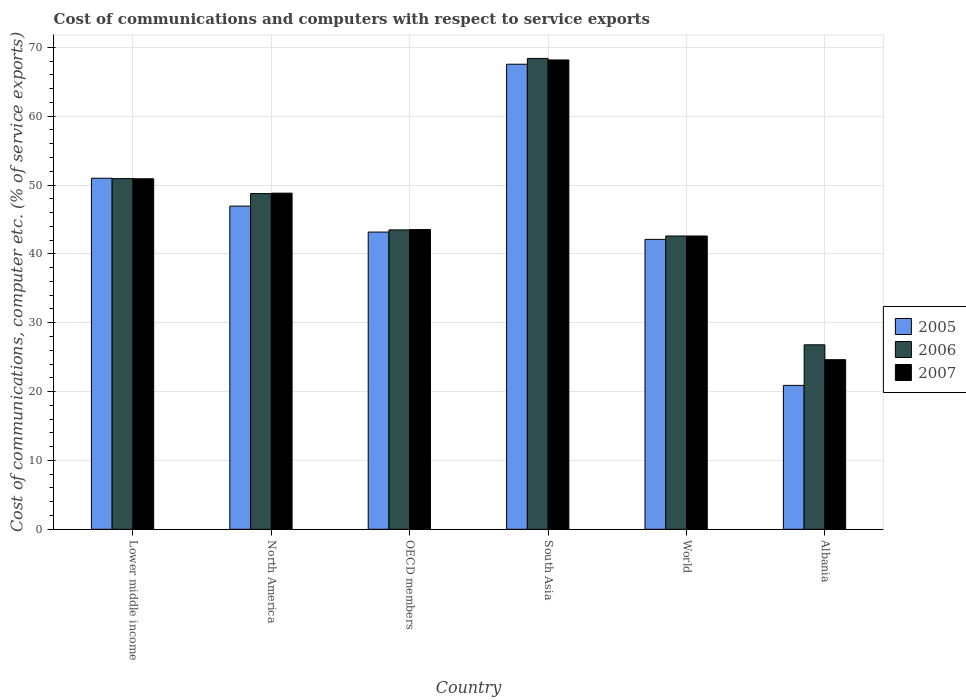Are the number of bars on each tick of the X-axis equal?
Give a very brief answer. Yes. What is the label of the 3rd group of bars from the left?
Offer a terse response. OECD members. What is the cost of communications and computers in 2005 in World?
Your answer should be compact. 42.1. Across all countries, what is the maximum cost of communications and computers in 2005?
Your answer should be compact. 67.54. Across all countries, what is the minimum cost of communications and computers in 2005?
Offer a terse response. 20.9. In which country was the cost of communications and computers in 2005 maximum?
Offer a very short reply. South Asia. In which country was the cost of communications and computers in 2007 minimum?
Give a very brief answer. Albania. What is the total cost of communications and computers in 2005 in the graph?
Your answer should be compact. 271.63. What is the difference between the cost of communications and computers in 2005 in Albania and that in OECD members?
Provide a short and direct response. -22.27. What is the difference between the cost of communications and computers in 2006 in World and the cost of communications and computers in 2007 in Lower middle income?
Offer a terse response. -8.31. What is the average cost of communications and computers in 2005 per country?
Offer a terse response. 45.27. What is the difference between the cost of communications and computers of/in 2005 and cost of communications and computers of/in 2006 in Albania?
Give a very brief answer. -5.89. In how many countries, is the cost of communications and computers in 2007 greater than 64 %?
Your answer should be compact. 1. What is the ratio of the cost of communications and computers in 2005 in Albania to that in North America?
Make the answer very short. 0.45. Is the difference between the cost of communications and computers in 2005 in OECD members and South Asia greater than the difference between the cost of communications and computers in 2006 in OECD members and South Asia?
Offer a very short reply. Yes. What is the difference between the highest and the second highest cost of communications and computers in 2007?
Provide a short and direct response. -2.09. What is the difference between the highest and the lowest cost of communications and computers in 2006?
Provide a succinct answer. 41.59. Is the sum of the cost of communications and computers in 2006 in OECD members and World greater than the maximum cost of communications and computers in 2005 across all countries?
Offer a very short reply. Yes. Is it the case that in every country, the sum of the cost of communications and computers in 2005 and cost of communications and computers in 2007 is greater than the cost of communications and computers in 2006?
Make the answer very short. Yes. Are all the bars in the graph horizontal?
Your response must be concise. No. What is the difference between two consecutive major ticks on the Y-axis?
Ensure brevity in your answer.  10. Are the values on the major ticks of Y-axis written in scientific E-notation?
Give a very brief answer. No. Does the graph contain grids?
Offer a terse response. Yes. What is the title of the graph?
Ensure brevity in your answer.  Cost of communications and computers with respect to service exports. Does "1986" appear as one of the legend labels in the graph?
Your response must be concise. No. What is the label or title of the Y-axis?
Make the answer very short. Cost of communications, computer etc. (% of service exports). What is the Cost of communications, computer etc. (% of service exports) of 2005 in Lower middle income?
Make the answer very short. 50.99. What is the Cost of communications, computer etc. (% of service exports) in 2006 in Lower middle income?
Keep it short and to the point. 50.93. What is the Cost of communications, computer etc. (% of service exports) in 2007 in Lower middle income?
Your answer should be compact. 50.91. What is the Cost of communications, computer etc. (% of service exports) in 2005 in North America?
Provide a succinct answer. 46.93. What is the Cost of communications, computer etc. (% of service exports) in 2006 in North America?
Offer a very short reply. 48.76. What is the Cost of communications, computer etc. (% of service exports) in 2007 in North America?
Provide a short and direct response. 48.82. What is the Cost of communications, computer etc. (% of service exports) of 2005 in OECD members?
Provide a short and direct response. 43.17. What is the Cost of communications, computer etc. (% of service exports) in 2006 in OECD members?
Keep it short and to the point. 43.48. What is the Cost of communications, computer etc. (% of service exports) in 2007 in OECD members?
Provide a succinct answer. 43.53. What is the Cost of communications, computer etc. (% of service exports) of 2005 in South Asia?
Provide a short and direct response. 67.54. What is the Cost of communications, computer etc. (% of service exports) in 2006 in South Asia?
Provide a short and direct response. 68.39. What is the Cost of communications, computer etc. (% of service exports) in 2007 in South Asia?
Keep it short and to the point. 68.16. What is the Cost of communications, computer etc. (% of service exports) of 2005 in World?
Ensure brevity in your answer.  42.1. What is the Cost of communications, computer etc. (% of service exports) in 2006 in World?
Your answer should be very brief. 42.59. What is the Cost of communications, computer etc. (% of service exports) in 2007 in World?
Provide a succinct answer. 42.59. What is the Cost of communications, computer etc. (% of service exports) in 2005 in Albania?
Provide a succinct answer. 20.9. What is the Cost of communications, computer etc. (% of service exports) in 2006 in Albania?
Provide a short and direct response. 26.79. What is the Cost of communications, computer etc. (% of service exports) of 2007 in Albania?
Give a very brief answer. 24.63. Across all countries, what is the maximum Cost of communications, computer etc. (% of service exports) in 2005?
Provide a succinct answer. 67.54. Across all countries, what is the maximum Cost of communications, computer etc. (% of service exports) of 2006?
Your answer should be compact. 68.39. Across all countries, what is the maximum Cost of communications, computer etc. (% of service exports) of 2007?
Your answer should be compact. 68.16. Across all countries, what is the minimum Cost of communications, computer etc. (% of service exports) in 2005?
Offer a terse response. 20.9. Across all countries, what is the minimum Cost of communications, computer etc. (% of service exports) of 2006?
Your response must be concise. 26.79. Across all countries, what is the minimum Cost of communications, computer etc. (% of service exports) in 2007?
Make the answer very short. 24.63. What is the total Cost of communications, computer etc. (% of service exports) of 2005 in the graph?
Offer a terse response. 271.63. What is the total Cost of communications, computer etc. (% of service exports) in 2006 in the graph?
Keep it short and to the point. 280.94. What is the total Cost of communications, computer etc. (% of service exports) of 2007 in the graph?
Keep it short and to the point. 278.64. What is the difference between the Cost of communications, computer etc. (% of service exports) of 2005 in Lower middle income and that in North America?
Give a very brief answer. 4.05. What is the difference between the Cost of communications, computer etc. (% of service exports) of 2006 in Lower middle income and that in North America?
Provide a short and direct response. 2.17. What is the difference between the Cost of communications, computer etc. (% of service exports) of 2007 in Lower middle income and that in North America?
Offer a terse response. 2.09. What is the difference between the Cost of communications, computer etc. (% of service exports) in 2005 in Lower middle income and that in OECD members?
Keep it short and to the point. 7.82. What is the difference between the Cost of communications, computer etc. (% of service exports) of 2006 in Lower middle income and that in OECD members?
Provide a short and direct response. 7.45. What is the difference between the Cost of communications, computer etc. (% of service exports) in 2007 in Lower middle income and that in OECD members?
Provide a short and direct response. 7.38. What is the difference between the Cost of communications, computer etc. (% of service exports) of 2005 in Lower middle income and that in South Asia?
Your answer should be very brief. -16.55. What is the difference between the Cost of communications, computer etc. (% of service exports) of 2006 in Lower middle income and that in South Asia?
Make the answer very short. -17.45. What is the difference between the Cost of communications, computer etc. (% of service exports) of 2007 in Lower middle income and that in South Asia?
Give a very brief answer. -17.25. What is the difference between the Cost of communications, computer etc. (% of service exports) in 2005 in Lower middle income and that in World?
Your answer should be very brief. 8.88. What is the difference between the Cost of communications, computer etc. (% of service exports) of 2006 in Lower middle income and that in World?
Give a very brief answer. 8.34. What is the difference between the Cost of communications, computer etc. (% of service exports) of 2007 in Lower middle income and that in World?
Your response must be concise. 8.31. What is the difference between the Cost of communications, computer etc. (% of service exports) of 2005 in Lower middle income and that in Albania?
Your response must be concise. 30.09. What is the difference between the Cost of communications, computer etc. (% of service exports) in 2006 in Lower middle income and that in Albania?
Offer a very short reply. 24.14. What is the difference between the Cost of communications, computer etc. (% of service exports) of 2007 in Lower middle income and that in Albania?
Offer a very short reply. 26.27. What is the difference between the Cost of communications, computer etc. (% of service exports) in 2005 in North America and that in OECD members?
Offer a terse response. 3.77. What is the difference between the Cost of communications, computer etc. (% of service exports) of 2006 in North America and that in OECD members?
Your answer should be very brief. 5.28. What is the difference between the Cost of communications, computer etc. (% of service exports) of 2007 in North America and that in OECD members?
Make the answer very short. 5.29. What is the difference between the Cost of communications, computer etc. (% of service exports) in 2005 in North America and that in South Asia?
Provide a succinct answer. -20.61. What is the difference between the Cost of communications, computer etc. (% of service exports) in 2006 in North America and that in South Asia?
Your response must be concise. -19.63. What is the difference between the Cost of communications, computer etc. (% of service exports) of 2007 in North America and that in South Asia?
Your answer should be compact. -19.34. What is the difference between the Cost of communications, computer etc. (% of service exports) of 2005 in North America and that in World?
Make the answer very short. 4.83. What is the difference between the Cost of communications, computer etc. (% of service exports) in 2006 in North America and that in World?
Offer a terse response. 6.16. What is the difference between the Cost of communications, computer etc. (% of service exports) in 2007 in North America and that in World?
Make the answer very short. 6.23. What is the difference between the Cost of communications, computer etc. (% of service exports) of 2005 in North America and that in Albania?
Offer a terse response. 26.03. What is the difference between the Cost of communications, computer etc. (% of service exports) of 2006 in North America and that in Albania?
Offer a very short reply. 21.97. What is the difference between the Cost of communications, computer etc. (% of service exports) in 2007 in North America and that in Albania?
Provide a succinct answer. 24.19. What is the difference between the Cost of communications, computer etc. (% of service exports) of 2005 in OECD members and that in South Asia?
Your answer should be compact. -24.37. What is the difference between the Cost of communications, computer etc. (% of service exports) of 2006 in OECD members and that in South Asia?
Provide a succinct answer. -24.9. What is the difference between the Cost of communications, computer etc. (% of service exports) in 2007 in OECD members and that in South Asia?
Offer a very short reply. -24.63. What is the difference between the Cost of communications, computer etc. (% of service exports) of 2005 in OECD members and that in World?
Provide a succinct answer. 1.06. What is the difference between the Cost of communications, computer etc. (% of service exports) of 2006 in OECD members and that in World?
Ensure brevity in your answer.  0.89. What is the difference between the Cost of communications, computer etc. (% of service exports) of 2007 in OECD members and that in World?
Keep it short and to the point. 0.94. What is the difference between the Cost of communications, computer etc. (% of service exports) of 2005 in OECD members and that in Albania?
Make the answer very short. 22.27. What is the difference between the Cost of communications, computer etc. (% of service exports) in 2006 in OECD members and that in Albania?
Provide a succinct answer. 16.69. What is the difference between the Cost of communications, computer etc. (% of service exports) of 2007 in OECD members and that in Albania?
Your answer should be compact. 18.9. What is the difference between the Cost of communications, computer etc. (% of service exports) of 2005 in South Asia and that in World?
Make the answer very short. 25.44. What is the difference between the Cost of communications, computer etc. (% of service exports) in 2006 in South Asia and that in World?
Your answer should be compact. 25.79. What is the difference between the Cost of communications, computer etc. (% of service exports) of 2007 in South Asia and that in World?
Give a very brief answer. 25.57. What is the difference between the Cost of communications, computer etc. (% of service exports) in 2005 in South Asia and that in Albania?
Your answer should be compact. 46.64. What is the difference between the Cost of communications, computer etc. (% of service exports) of 2006 in South Asia and that in Albania?
Make the answer very short. 41.59. What is the difference between the Cost of communications, computer etc. (% of service exports) in 2007 in South Asia and that in Albania?
Give a very brief answer. 43.53. What is the difference between the Cost of communications, computer etc. (% of service exports) in 2005 in World and that in Albania?
Offer a terse response. 21.2. What is the difference between the Cost of communications, computer etc. (% of service exports) of 2006 in World and that in Albania?
Offer a terse response. 15.8. What is the difference between the Cost of communications, computer etc. (% of service exports) of 2007 in World and that in Albania?
Your response must be concise. 17.96. What is the difference between the Cost of communications, computer etc. (% of service exports) in 2005 in Lower middle income and the Cost of communications, computer etc. (% of service exports) in 2006 in North America?
Your answer should be compact. 2.23. What is the difference between the Cost of communications, computer etc. (% of service exports) of 2005 in Lower middle income and the Cost of communications, computer etc. (% of service exports) of 2007 in North America?
Ensure brevity in your answer.  2.17. What is the difference between the Cost of communications, computer etc. (% of service exports) in 2006 in Lower middle income and the Cost of communications, computer etc. (% of service exports) in 2007 in North America?
Ensure brevity in your answer.  2.11. What is the difference between the Cost of communications, computer etc. (% of service exports) of 2005 in Lower middle income and the Cost of communications, computer etc. (% of service exports) of 2006 in OECD members?
Offer a very short reply. 7.5. What is the difference between the Cost of communications, computer etc. (% of service exports) of 2005 in Lower middle income and the Cost of communications, computer etc. (% of service exports) of 2007 in OECD members?
Keep it short and to the point. 7.46. What is the difference between the Cost of communications, computer etc. (% of service exports) of 2006 in Lower middle income and the Cost of communications, computer etc. (% of service exports) of 2007 in OECD members?
Ensure brevity in your answer.  7.4. What is the difference between the Cost of communications, computer etc. (% of service exports) of 2005 in Lower middle income and the Cost of communications, computer etc. (% of service exports) of 2006 in South Asia?
Keep it short and to the point. -17.4. What is the difference between the Cost of communications, computer etc. (% of service exports) of 2005 in Lower middle income and the Cost of communications, computer etc. (% of service exports) of 2007 in South Asia?
Make the answer very short. -17.18. What is the difference between the Cost of communications, computer etc. (% of service exports) of 2006 in Lower middle income and the Cost of communications, computer etc. (% of service exports) of 2007 in South Asia?
Give a very brief answer. -17.23. What is the difference between the Cost of communications, computer etc. (% of service exports) of 2005 in Lower middle income and the Cost of communications, computer etc. (% of service exports) of 2006 in World?
Make the answer very short. 8.39. What is the difference between the Cost of communications, computer etc. (% of service exports) of 2005 in Lower middle income and the Cost of communications, computer etc. (% of service exports) of 2007 in World?
Provide a short and direct response. 8.39. What is the difference between the Cost of communications, computer etc. (% of service exports) in 2006 in Lower middle income and the Cost of communications, computer etc. (% of service exports) in 2007 in World?
Your response must be concise. 8.34. What is the difference between the Cost of communications, computer etc. (% of service exports) in 2005 in Lower middle income and the Cost of communications, computer etc. (% of service exports) in 2006 in Albania?
Offer a terse response. 24.19. What is the difference between the Cost of communications, computer etc. (% of service exports) of 2005 in Lower middle income and the Cost of communications, computer etc. (% of service exports) of 2007 in Albania?
Give a very brief answer. 26.35. What is the difference between the Cost of communications, computer etc. (% of service exports) in 2006 in Lower middle income and the Cost of communications, computer etc. (% of service exports) in 2007 in Albania?
Give a very brief answer. 26.3. What is the difference between the Cost of communications, computer etc. (% of service exports) in 2005 in North America and the Cost of communications, computer etc. (% of service exports) in 2006 in OECD members?
Give a very brief answer. 3.45. What is the difference between the Cost of communications, computer etc. (% of service exports) in 2005 in North America and the Cost of communications, computer etc. (% of service exports) in 2007 in OECD members?
Your answer should be compact. 3.41. What is the difference between the Cost of communications, computer etc. (% of service exports) in 2006 in North America and the Cost of communications, computer etc. (% of service exports) in 2007 in OECD members?
Ensure brevity in your answer.  5.23. What is the difference between the Cost of communications, computer etc. (% of service exports) in 2005 in North America and the Cost of communications, computer etc. (% of service exports) in 2006 in South Asia?
Make the answer very short. -21.45. What is the difference between the Cost of communications, computer etc. (% of service exports) of 2005 in North America and the Cost of communications, computer etc. (% of service exports) of 2007 in South Asia?
Make the answer very short. -21.23. What is the difference between the Cost of communications, computer etc. (% of service exports) of 2006 in North America and the Cost of communications, computer etc. (% of service exports) of 2007 in South Asia?
Your response must be concise. -19.4. What is the difference between the Cost of communications, computer etc. (% of service exports) in 2005 in North America and the Cost of communications, computer etc. (% of service exports) in 2006 in World?
Provide a succinct answer. 4.34. What is the difference between the Cost of communications, computer etc. (% of service exports) of 2005 in North America and the Cost of communications, computer etc. (% of service exports) of 2007 in World?
Make the answer very short. 4.34. What is the difference between the Cost of communications, computer etc. (% of service exports) in 2006 in North America and the Cost of communications, computer etc. (% of service exports) in 2007 in World?
Your response must be concise. 6.16. What is the difference between the Cost of communications, computer etc. (% of service exports) of 2005 in North America and the Cost of communications, computer etc. (% of service exports) of 2006 in Albania?
Provide a succinct answer. 20.14. What is the difference between the Cost of communications, computer etc. (% of service exports) in 2005 in North America and the Cost of communications, computer etc. (% of service exports) in 2007 in Albania?
Provide a succinct answer. 22.3. What is the difference between the Cost of communications, computer etc. (% of service exports) of 2006 in North America and the Cost of communications, computer etc. (% of service exports) of 2007 in Albania?
Ensure brevity in your answer.  24.13. What is the difference between the Cost of communications, computer etc. (% of service exports) in 2005 in OECD members and the Cost of communications, computer etc. (% of service exports) in 2006 in South Asia?
Ensure brevity in your answer.  -25.22. What is the difference between the Cost of communications, computer etc. (% of service exports) in 2005 in OECD members and the Cost of communications, computer etc. (% of service exports) in 2007 in South Asia?
Offer a very short reply. -24.99. What is the difference between the Cost of communications, computer etc. (% of service exports) in 2006 in OECD members and the Cost of communications, computer etc. (% of service exports) in 2007 in South Asia?
Keep it short and to the point. -24.68. What is the difference between the Cost of communications, computer etc. (% of service exports) of 2005 in OECD members and the Cost of communications, computer etc. (% of service exports) of 2006 in World?
Ensure brevity in your answer.  0.57. What is the difference between the Cost of communications, computer etc. (% of service exports) of 2005 in OECD members and the Cost of communications, computer etc. (% of service exports) of 2007 in World?
Offer a terse response. 0.57. What is the difference between the Cost of communications, computer etc. (% of service exports) of 2006 in OECD members and the Cost of communications, computer etc. (% of service exports) of 2007 in World?
Give a very brief answer. 0.89. What is the difference between the Cost of communications, computer etc. (% of service exports) in 2005 in OECD members and the Cost of communications, computer etc. (% of service exports) in 2006 in Albania?
Keep it short and to the point. 16.38. What is the difference between the Cost of communications, computer etc. (% of service exports) of 2005 in OECD members and the Cost of communications, computer etc. (% of service exports) of 2007 in Albania?
Provide a succinct answer. 18.53. What is the difference between the Cost of communications, computer etc. (% of service exports) of 2006 in OECD members and the Cost of communications, computer etc. (% of service exports) of 2007 in Albania?
Provide a short and direct response. 18.85. What is the difference between the Cost of communications, computer etc. (% of service exports) in 2005 in South Asia and the Cost of communications, computer etc. (% of service exports) in 2006 in World?
Give a very brief answer. 24.95. What is the difference between the Cost of communications, computer etc. (% of service exports) in 2005 in South Asia and the Cost of communications, computer etc. (% of service exports) in 2007 in World?
Provide a succinct answer. 24.95. What is the difference between the Cost of communications, computer etc. (% of service exports) of 2006 in South Asia and the Cost of communications, computer etc. (% of service exports) of 2007 in World?
Give a very brief answer. 25.79. What is the difference between the Cost of communications, computer etc. (% of service exports) in 2005 in South Asia and the Cost of communications, computer etc. (% of service exports) in 2006 in Albania?
Your answer should be very brief. 40.75. What is the difference between the Cost of communications, computer etc. (% of service exports) of 2005 in South Asia and the Cost of communications, computer etc. (% of service exports) of 2007 in Albania?
Your answer should be compact. 42.91. What is the difference between the Cost of communications, computer etc. (% of service exports) of 2006 in South Asia and the Cost of communications, computer etc. (% of service exports) of 2007 in Albania?
Make the answer very short. 43.75. What is the difference between the Cost of communications, computer etc. (% of service exports) in 2005 in World and the Cost of communications, computer etc. (% of service exports) in 2006 in Albania?
Ensure brevity in your answer.  15.31. What is the difference between the Cost of communications, computer etc. (% of service exports) in 2005 in World and the Cost of communications, computer etc. (% of service exports) in 2007 in Albania?
Provide a short and direct response. 17.47. What is the difference between the Cost of communications, computer etc. (% of service exports) of 2006 in World and the Cost of communications, computer etc. (% of service exports) of 2007 in Albania?
Provide a short and direct response. 17.96. What is the average Cost of communications, computer etc. (% of service exports) of 2005 per country?
Provide a succinct answer. 45.27. What is the average Cost of communications, computer etc. (% of service exports) of 2006 per country?
Provide a short and direct response. 46.82. What is the average Cost of communications, computer etc. (% of service exports) of 2007 per country?
Offer a very short reply. 46.44. What is the difference between the Cost of communications, computer etc. (% of service exports) in 2005 and Cost of communications, computer etc. (% of service exports) in 2006 in Lower middle income?
Your answer should be very brief. 0.06. What is the difference between the Cost of communications, computer etc. (% of service exports) of 2005 and Cost of communications, computer etc. (% of service exports) of 2007 in Lower middle income?
Keep it short and to the point. 0.08. What is the difference between the Cost of communications, computer etc. (% of service exports) of 2006 and Cost of communications, computer etc. (% of service exports) of 2007 in Lower middle income?
Offer a terse response. 0.02. What is the difference between the Cost of communications, computer etc. (% of service exports) of 2005 and Cost of communications, computer etc. (% of service exports) of 2006 in North America?
Your response must be concise. -1.82. What is the difference between the Cost of communications, computer etc. (% of service exports) in 2005 and Cost of communications, computer etc. (% of service exports) in 2007 in North America?
Your answer should be compact. -1.88. What is the difference between the Cost of communications, computer etc. (% of service exports) of 2006 and Cost of communications, computer etc. (% of service exports) of 2007 in North America?
Give a very brief answer. -0.06. What is the difference between the Cost of communications, computer etc. (% of service exports) in 2005 and Cost of communications, computer etc. (% of service exports) in 2006 in OECD members?
Provide a short and direct response. -0.32. What is the difference between the Cost of communications, computer etc. (% of service exports) in 2005 and Cost of communications, computer etc. (% of service exports) in 2007 in OECD members?
Give a very brief answer. -0.36. What is the difference between the Cost of communications, computer etc. (% of service exports) in 2006 and Cost of communications, computer etc. (% of service exports) in 2007 in OECD members?
Give a very brief answer. -0.05. What is the difference between the Cost of communications, computer etc. (% of service exports) of 2005 and Cost of communications, computer etc. (% of service exports) of 2006 in South Asia?
Make the answer very short. -0.84. What is the difference between the Cost of communications, computer etc. (% of service exports) in 2005 and Cost of communications, computer etc. (% of service exports) in 2007 in South Asia?
Your answer should be compact. -0.62. What is the difference between the Cost of communications, computer etc. (% of service exports) of 2006 and Cost of communications, computer etc. (% of service exports) of 2007 in South Asia?
Give a very brief answer. 0.22. What is the difference between the Cost of communications, computer etc. (% of service exports) of 2005 and Cost of communications, computer etc. (% of service exports) of 2006 in World?
Your answer should be very brief. -0.49. What is the difference between the Cost of communications, computer etc. (% of service exports) of 2005 and Cost of communications, computer etc. (% of service exports) of 2007 in World?
Provide a succinct answer. -0.49. What is the difference between the Cost of communications, computer etc. (% of service exports) in 2006 and Cost of communications, computer etc. (% of service exports) in 2007 in World?
Offer a very short reply. 0. What is the difference between the Cost of communications, computer etc. (% of service exports) in 2005 and Cost of communications, computer etc. (% of service exports) in 2006 in Albania?
Offer a very short reply. -5.89. What is the difference between the Cost of communications, computer etc. (% of service exports) in 2005 and Cost of communications, computer etc. (% of service exports) in 2007 in Albania?
Make the answer very short. -3.73. What is the difference between the Cost of communications, computer etc. (% of service exports) in 2006 and Cost of communications, computer etc. (% of service exports) in 2007 in Albania?
Give a very brief answer. 2.16. What is the ratio of the Cost of communications, computer etc. (% of service exports) of 2005 in Lower middle income to that in North America?
Make the answer very short. 1.09. What is the ratio of the Cost of communications, computer etc. (% of service exports) in 2006 in Lower middle income to that in North America?
Provide a short and direct response. 1.04. What is the ratio of the Cost of communications, computer etc. (% of service exports) of 2007 in Lower middle income to that in North America?
Make the answer very short. 1.04. What is the ratio of the Cost of communications, computer etc. (% of service exports) of 2005 in Lower middle income to that in OECD members?
Your answer should be compact. 1.18. What is the ratio of the Cost of communications, computer etc. (% of service exports) of 2006 in Lower middle income to that in OECD members?
Your answer should be compact. 1.17. What is the ratio of the Cost of communications, computer etc. (% of service exports) of 2007 in Lower middle income to that in OECD members?
Give a very brief answer. 1.17. What is the ratio of the Cost of communications, computer etc. (% of service exports) in 2005 in Lower middle income to that in South Asia?
Your answer should be very brief. 0.75. What is the ratio of the Cost of communications, computer etc. (% of service exports) of 2006 in Lower middle income to that in South Asia?
Offer a very short reply. 0.74. What is the ratio of the Cost of communications, computer etc. (% of service exports) of 2007 in Lower middle income to that in South Asia?
Make the answer very short. 0.75. What is the ratio of the Cost of communications, computer etc. (% of service exports) of 2005 in Lower middle income to that in World?
Your response must be concise. 1.21. What is the ratio of the Cost of communications, computer etc. (% of service exports) in 2006 in Lower middle income to that in World?
Provide a short and direct response. 1.2. What is the ratio of the Cost of communications, computer etc. (% of service exports) of 2007 in Lower middle income to that in World?
Your answer should be very brief. 1.2. What is the ratio of the Cost of communications, computer etc. (% of service exports) in 2005 in Lower middle income to that in Albania?
Provide a succinct answer. 2.44. What is the ratio of the Cost of communications, computer etc. (% of service exports) in 2006 in Lower middle income to that in Albania?
Offer a very short reply. 1.9. What is the ratio of the Cost of communications, computer etc. (% of service exports) in 2007 in Lower middle income to that in Albania?
Your answer should be compact. 2.07. What is the ratio of the Cost of communications, computer etc. (% of service exports) in 2005 in North America to that in OECD members?
Make the answer very short. 1.09. What is the ratio of the Cost of communications, computer etc. (% of service exports) of 2006 in North America to that in OECD members?
Ensure brevity in your answer.  1.12. What is the ratio of the Cost of communications, computer etc. (% of service exports) in 2007 in North America to that in OECD members?
Give a very brief answer. 1.12. What is the ratio of the Cost of communications, computer etc. (% of service exports) in 2005 in North America to that in South Asia?
Give a very brief answer. 0.69. What is the ratio of the Cost of communications, computer etc. (% of service exports) of 2006 in North America to that in South Asia?
Provide a succinct answer. 0.71. What is the ratio of the Cost of communications, computer etc. (% of service exports) in 2007 in North America to that in South Asia?
Provide a short and direct response. 0.72. What is the ratio of the Cost of communications, computer etc. (% of service exports) of 2005 in North America to that in World?
Offer a terse response. 1.11. What is the ratio of the Cost of communications, computer etc. (% of service exports) of 2006 in North America to that in World?
Your answer should be very brief. 1.14. What is the ratio of the Cost of communications, computer etc. (% of service exports) of 2007 in North America to that in World?
Your answer should be very brief. 1.15. What is the ratio of the Cost of communications, computer etc. (% of service exports) of 2005 in North America to that in Albania?
Your response must be concise. 2.25. What is the ratio of the Cost of communications, computer etc. (% of service exports) of 2006 in North America to that in Albania?
Your answer should be very brief. 1.82. What is the ratio of the Cost of communications, computer etc. (% of service exports) in 2007 in North America to that in Albania?
Your response must be concise. 1.98. What is the ratio of the Cost of communications, computer etc. (% of service exports) in 2005 in OECD members to that in South Asia?
Make the answer very short. 0.64. What is the ratio of the Cost of communications, computer etc. (% of service exports) of 2006 in OECD members to that in South Asia?
Your answer should be very brief. 0.64. What is the ratio of the Cost of communications, computer etc. (% of service exports) in 2007 in OECD members to that in South Asia?
Offer a very short reply. 0.64. What is the ratio of the Cost of communications, computer etc. (% of service exports) of 2005 in OECD members to that in World?
Keep it short and to the point. 1.03. What is the ratio of the Cost of communications, computer etc. (% of service exports) of 2006 in OECD members to that in World?
Make the answer very short. 1.02. What is the ratio of the Cost of communications, computer etc. (% of service exports) of 2007 in OECD members to that in World?
Ensure brevity in your answer.  1.02. What is the ratio of the Cost of communications, computer etc. (% of service exports) of 2005 in OECD members to that in Albania?
Make the answer very short. 2.07. What is the ratio of the Cost of communications, computer etc. (% of service exports) of 2006 in OECD members to that in Albania?
Keep it short and to the point. 1.62. What is the ratio of the Cost of communications, computer etc. (% of service exports) in 2007 in OECD members to that in Albania?
Provide a short and direct response. 1.77. What is the ratio of the Cost of communications, computer etc. (% of service exports) of 2005 in South Asia to that in World?
Offer a very short reply. 1.6. What is the ratio of the Cost of communications, computer etc. (% of service exports) in 2006 in South Asia to that in World?
Provide a short and direct response. 1.61. What is the ratio of the Cost of communications, computer etc. (% of service exports) in 2007 in South Asia to that in World?
Your answer should be very brief. 1.6. What is the ratio of the Cost of communications, computer etc. (% of service exports) of 2005 in South Asia to that in Albania?
Offer a very short reply. 3.23. What is the ratio of the Cost of communications, computer etc. (% of service exports) in 2006 in South Asia to that in Albania?
Ensure brevity in your answer.  2.55. What is the ratio of the Cost of communications, computer etc. (% of service exports) of 2007 in South Asia to that in Albania?
Ensure brevity in your answer.  2.77. What is the ratio of the Cost of communications, computer etc. (% of service exports) in 2005 in World to that in Albania?
Offer a terse response. 2.01. What is the ratio of the Cost of communications, computer etc. (% of service exports) of 2006 in World to that in Albania?
Ensure brevity in your answer.  1.59. What is the ratio of the Cost of communications, computer etc. (% of service exports) in 2007 in World to that in Albania?
Keep it short and to the point. 1.73. What is the difference between the highest and the second highest Cost of communications, computer etc. (% of service exports) in 2005?
Offer a very short reply. 16.55. What is the difference between the highest and the second highest Cost of communications, computer etc. (% of service exports) in 2006?
Keep it short and to the point. 17.45. What is the difference between the highest and the second highest Cost of communications, computer etc. (% of service exports) in 2007?
Provide a short and direct response. 17.25. What is the difference between the highest and the lowest Cost of communications, computer etc. (% of service exports) of 2005?
Your answer should be compact. 46.64. What is the difference between the highest and the lowest Cost of communications, computer etc. (% of service exports) of 2006?
Offer a terse response. 41.59. What is the difference between the highest and the lowest Cost of communications, computer etc. (% of service exports) in 2007?
Offer a very short reply. 43.53. 